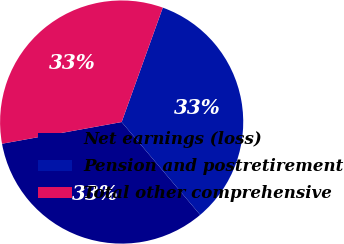<chart> <loc_0><loc_0><loc_500><loc_500><pie_chart><fcel>Net earnings (loss)<fcel>Pension and postretirement<fcel>Total other comprehensive<nl><fcel>33.32%<fcel>33.33%<fcel>33.35%<nl></chart> 